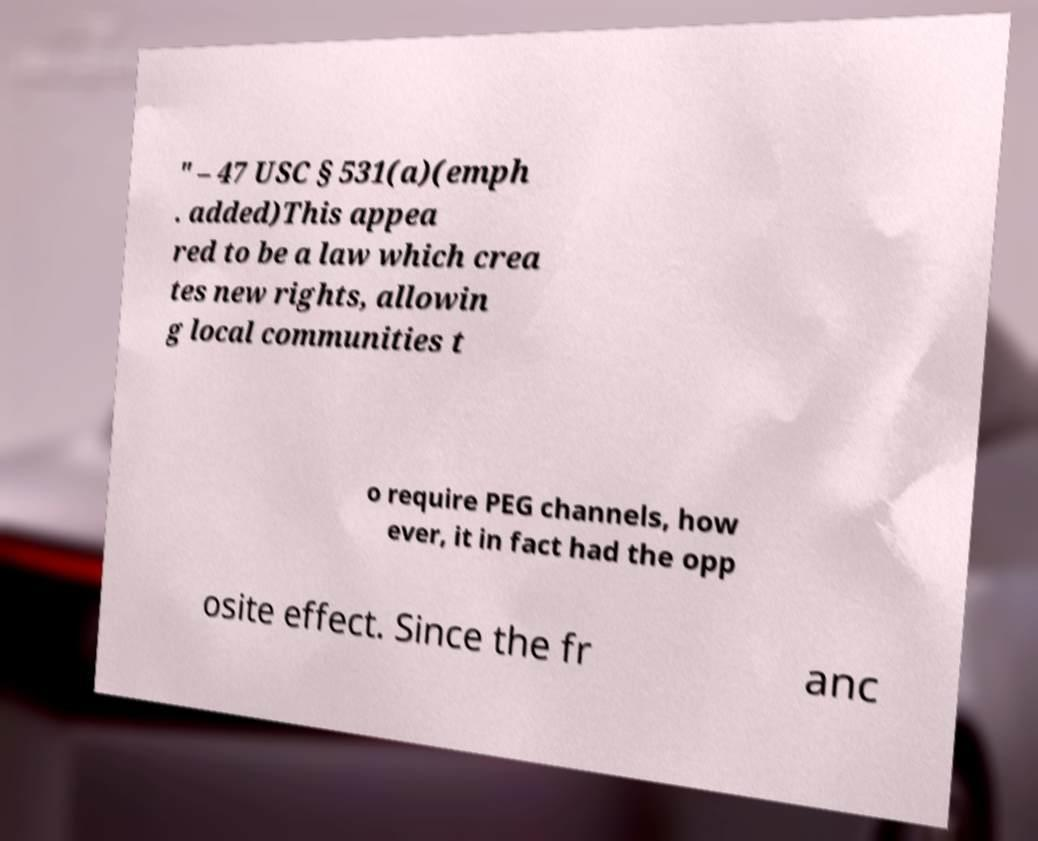Could you assist in decoding the text presented in this image and type it out clearly? " – 47 USC § 531(a)(emph . added)This appea red to be a law which crea tes new rights, allowin g local communities t o require PEG channels, how ever, it in fact had the opp osite effect. Since the fr anc 